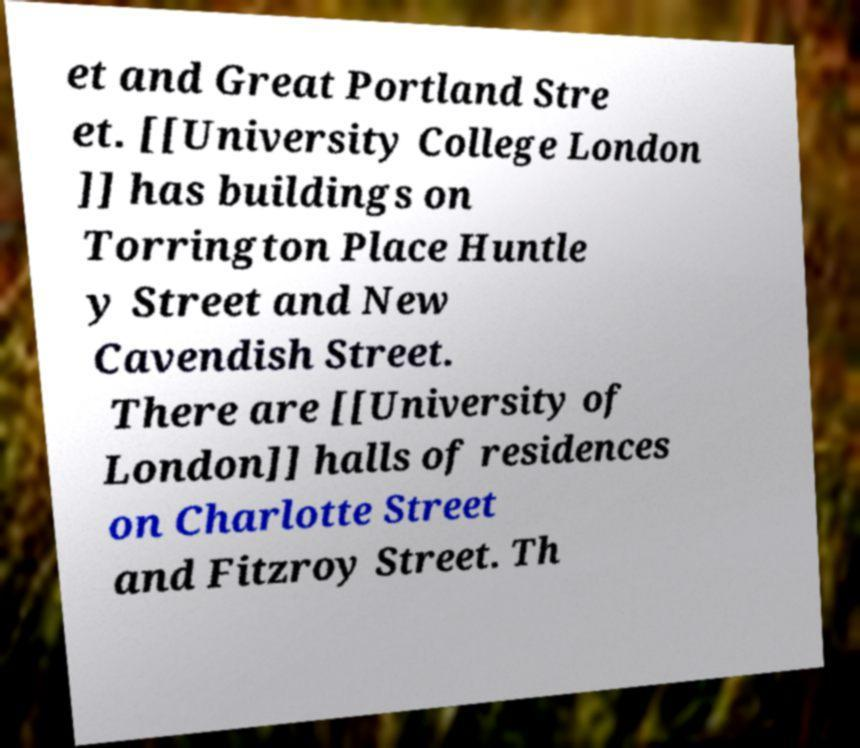Could you extract and type out the text from this image? et and Great Portland Stre et. [[University College London ]] has buildings on Torrington Place Huntle y Street and New Cavendish Street. There are [[University of London]] halls of residences on Charlotte Street and Fitzroy Street. Th 